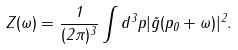<formula> <loc_0><loc_0><loc_500><loc_500>Z ( \omega ) = \frac { 1 } { ( 2 \pi ) ^ { 3 } } \int d ^ { 3 } p | \tilde { g } ( p _ { 0 } + \omega ) | ^ { 2 } .</formula> 